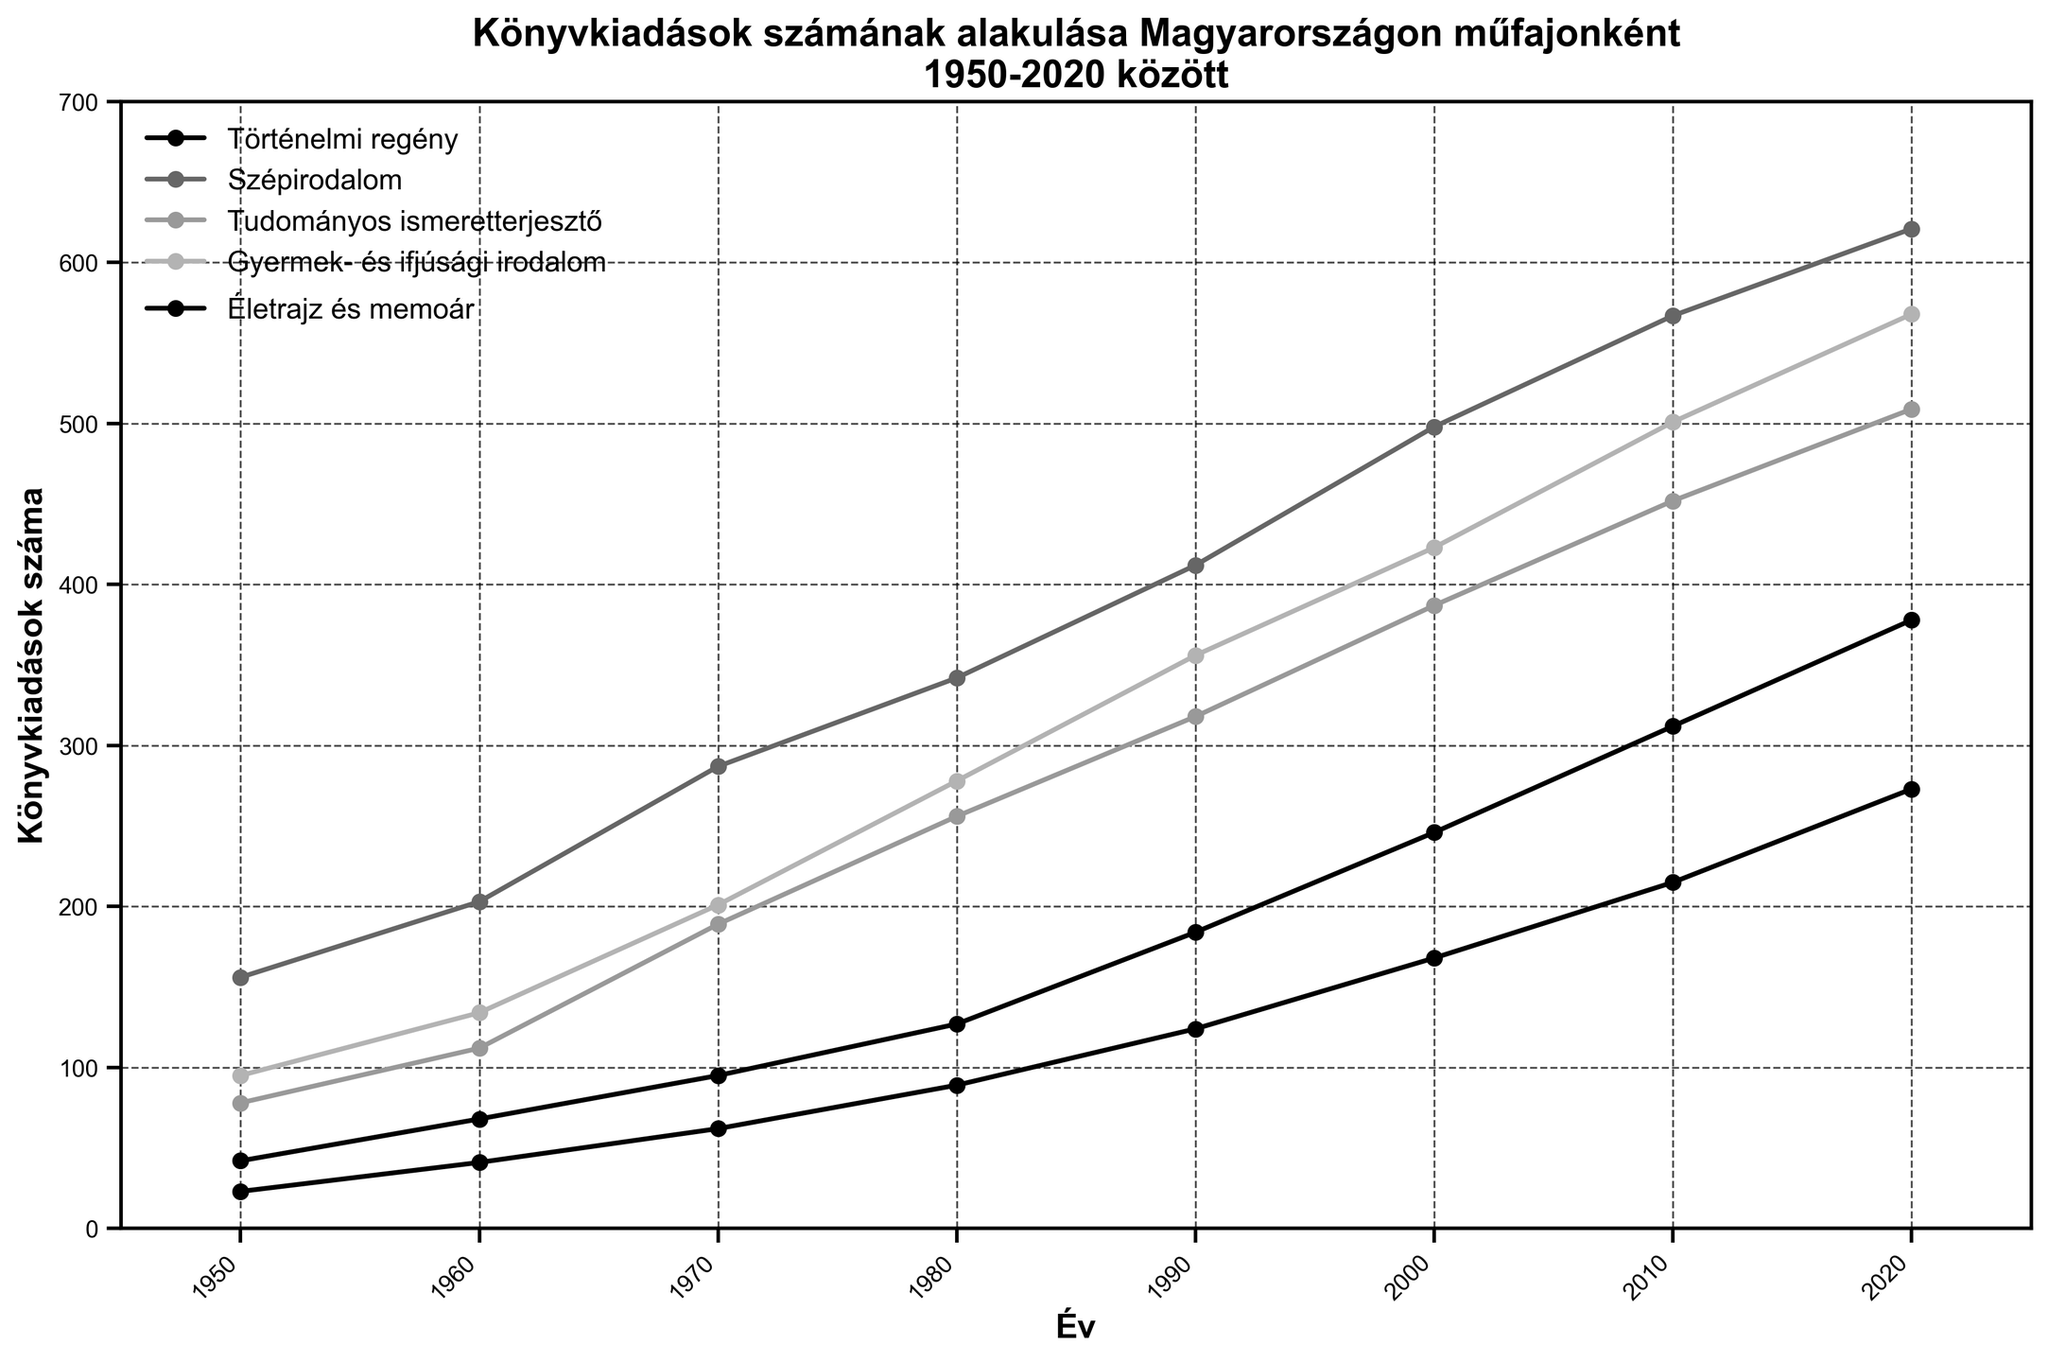Melyik műfaj könyvkiadásában volt a legnagyobb növekedés 1950 és 2020 között? Nézzük meg a kiindulási és a végső év könyvkiadásainak számát minden műfaj esetében. Számítsuk ki a különbséget a 2020 és az 1950 értékei között minden műfajra, majd keressük meg a legnagyobb különbséget.
Answer: Szépirodalom Melyik évben adottak ki a legtöbb könyvet tudományos ismeretterjesztő műfajban? Nézd meg a tudományos ismeretterjesztő könyvkiadások számát az összes évben, majd keresd meg a legnagyobb értéket és annak évét.
Answer: 2020 Mennyivel több szépirodalmi könyvet adtak ki 2020-ban, mint 1950-ben? Keresd meg a szépirodalmi könyvkiadások számát 2020-ban és 1950-ben, majd vond ki az 1950-es értéket a 2020-asból.
Answer: 465 Melyik műfaj könyvkiadásainak száma nőtt a legkevesebb mértékben 1950 és 2020 között? Számítsd ki a különbséget a 2020-as és az 1950-es év könyvkiadásainak száma között minden műfajnál, majd keresd meg a legkisebb különbséget.
Answer: Életrajz és memoár Melyik két műfaj könyvkiadásainak száma volt a legközelebb egymáshoz 1980-ban? Nézd meg 1980-as év adatait, majd számítsd ki a különbségeket minden párosítás között. A legkisebb különbség adja a két legközelebbi értéket.
Answer: Történelmi regény és Életrajz és memoár Melyik műfaj könyvkiadásainak száma csökkent egy évben sem a vizsgált időszak alatt? Figyeld meg minden műfaj adatait az összes évben, és ellenőrizd, hogy van-e olyan év, amikor a könyvkiadásuk csökkent az előző évhez képest. A műfaj, amelyik minden évben növekedett, a válasz.
Answer: Szépirodalom Melyik évben volt a legnagyobb különbség a történelmi regény és a gyermek- és ifjúsági irodalom könyvkiadásainak száma között? Nézd meg minden év történelmi regény és gyermek- és ifjúsági irodalom könyvkiadásainak számát, számítsd ki a különbségeket, majd keresd meg a legnagyobb különbséget és annak évét.
Answer: 2020 